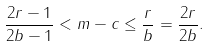Convert formula to latex. <formula><loc_0><loc_0><loc_500><loc_500>\frac { 2 r - 1 } { 2 b - 1 } < m - c \leq \frac { r } { b } = \frac { 2 r } { 2 b } .</formula> 